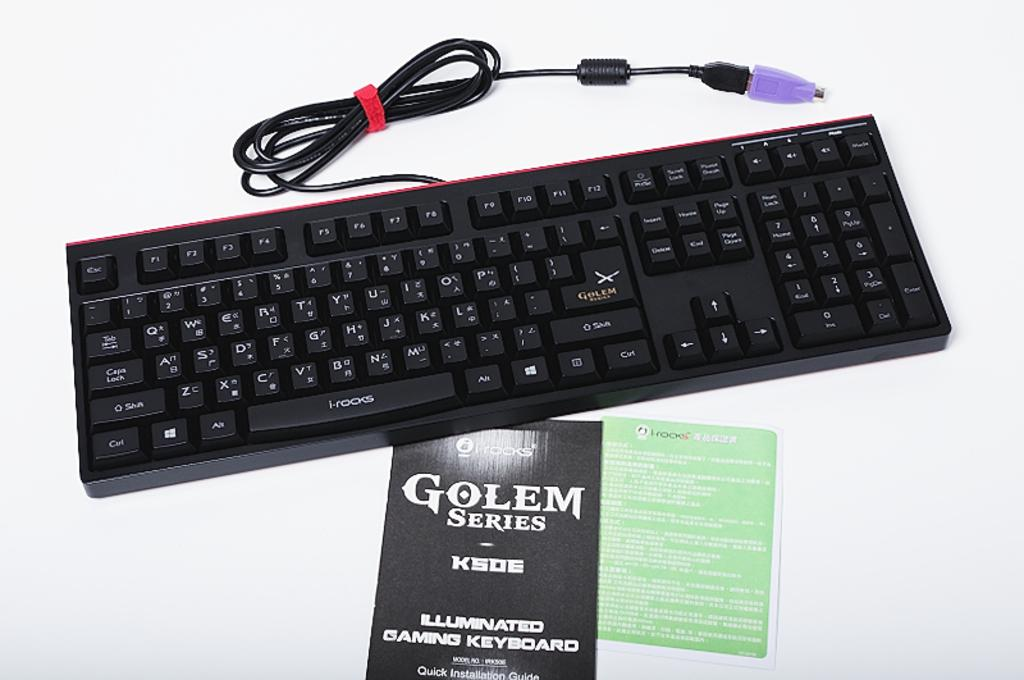Provide a one-sentence caption for the provided image. A keyboard on top of a booklet of the keyboard called "Golem Series". 